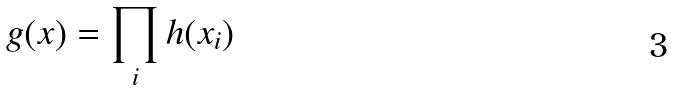Convert formula to latex. <formula><loc_0><loc_0><loc_500><loc_500>g ( x ) = \prod _ { i } h ( x _ { i } )</formula> 